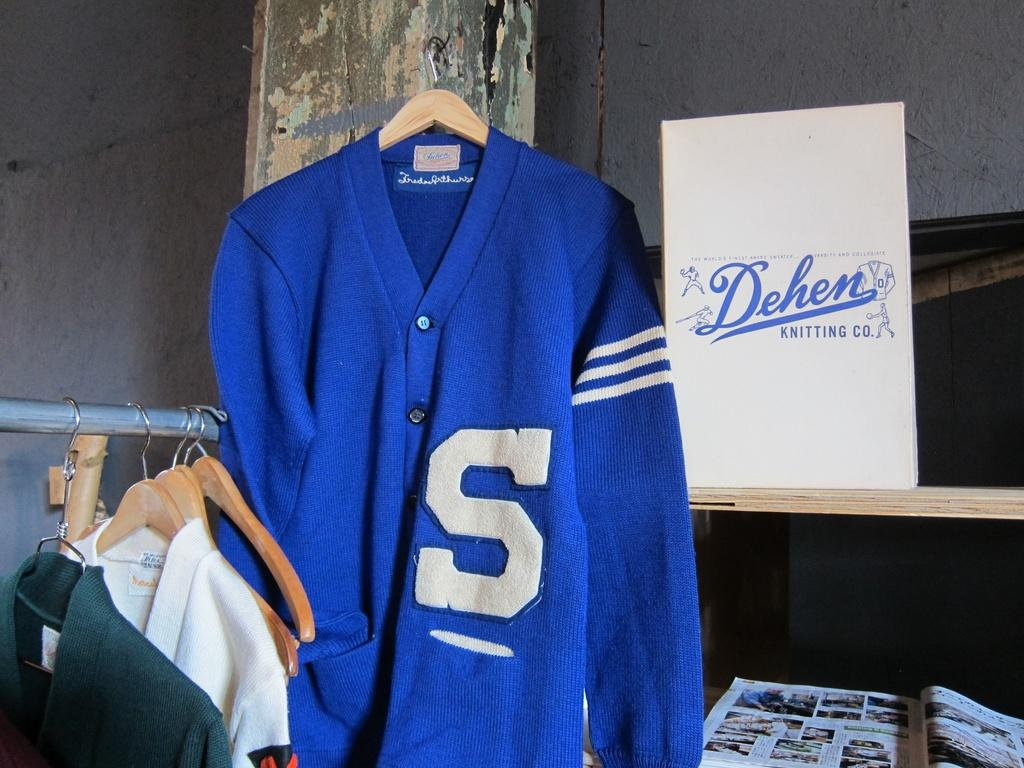Provide a one-sentence caption for the provided image. A Dehen blue sweater in some kind of stuff hanging up on the wall. 